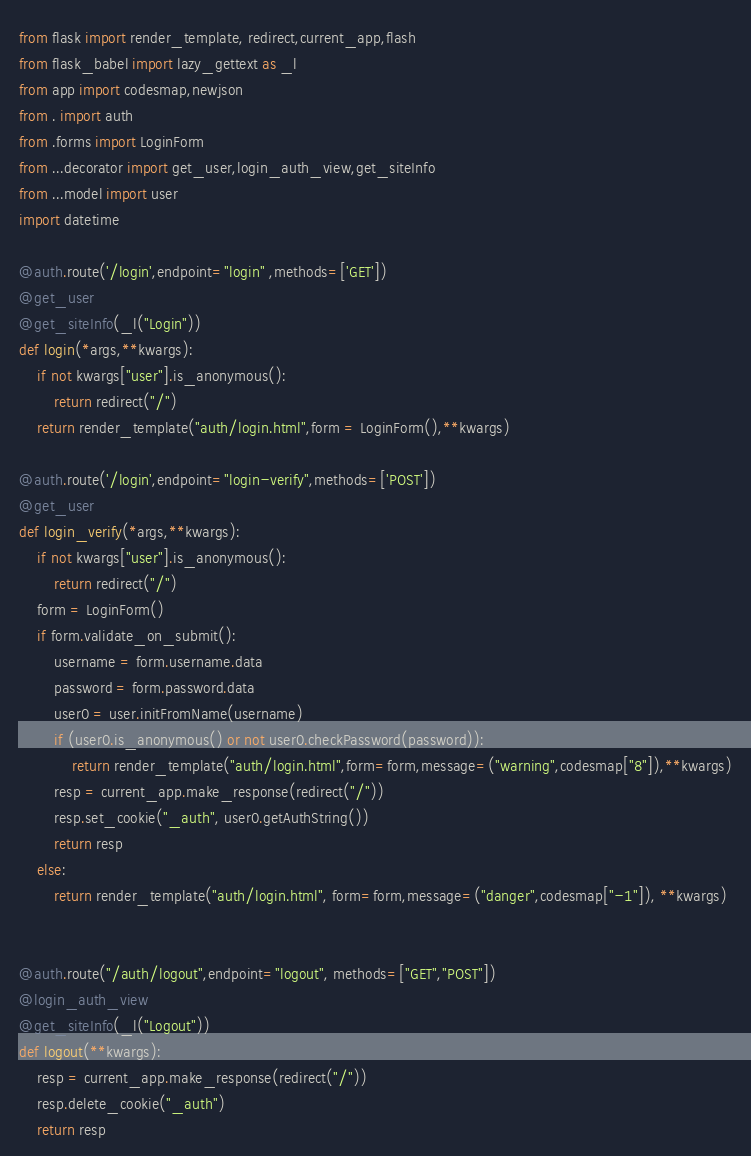Convert code to text. <code><loc_0><loc_0><loc_500><loc_500><_Python_>from flask import render_template, redirect,current_app,flash
from flask_babel import lazy_gettext as _l
from app import codesmap,newjson
from . import auth
from .forms import LoginForm
from ...decorator import get_user,login_auth_view,get_siteInfo
from ...model import user
import datetime

@auth.route('/login',endpoint="login" ,methods=['GET'])
@get_user
@get_siteInfo(_l("Login"))
def login(*args,**kwargs):
    if not kwargs["user"].is_anonymous():
        return redirect("/")
    return render_template("auth/login.html",form = LoginForm(),**kwargs)

@auth.route('/login',endpoint="login-verify",methods=['POST'])
@get_user
def login_verify(*args,**kwargs):
    if not kwargs["user"].is_anonymous():
        return redirect("/")
    form = LoginForm()
    if form.validate_on_submit():
        username = form.username.data
        password = form.password.data
        user0 = user.initFromName(username)
        if (user0.is_anonymous() or not user0.checkPassword(password)):
            return render_template("auth/login.html",form=form,message=("warning",codesmap["8"]),**kwargs)
        resp = current_app.make_response(redirect("/"))
        resp.set_cookie("_auth", user0.getAuthString())
        return resp
    else:
        return render_template("auth/login.html", form=form,message=("danger",codesmap["-1"]), **kwargs)


@auth.route("/auth/logout",endpoint="logout", methods=["GET","POST"])
@login_auth_view
@get_siteInfo(_l("Logout"))
def logout(**kwargs):
    resp = current_app.make_response(redirect("/"))
    resp.delete_cookie("_auth")
    return resp</code> 